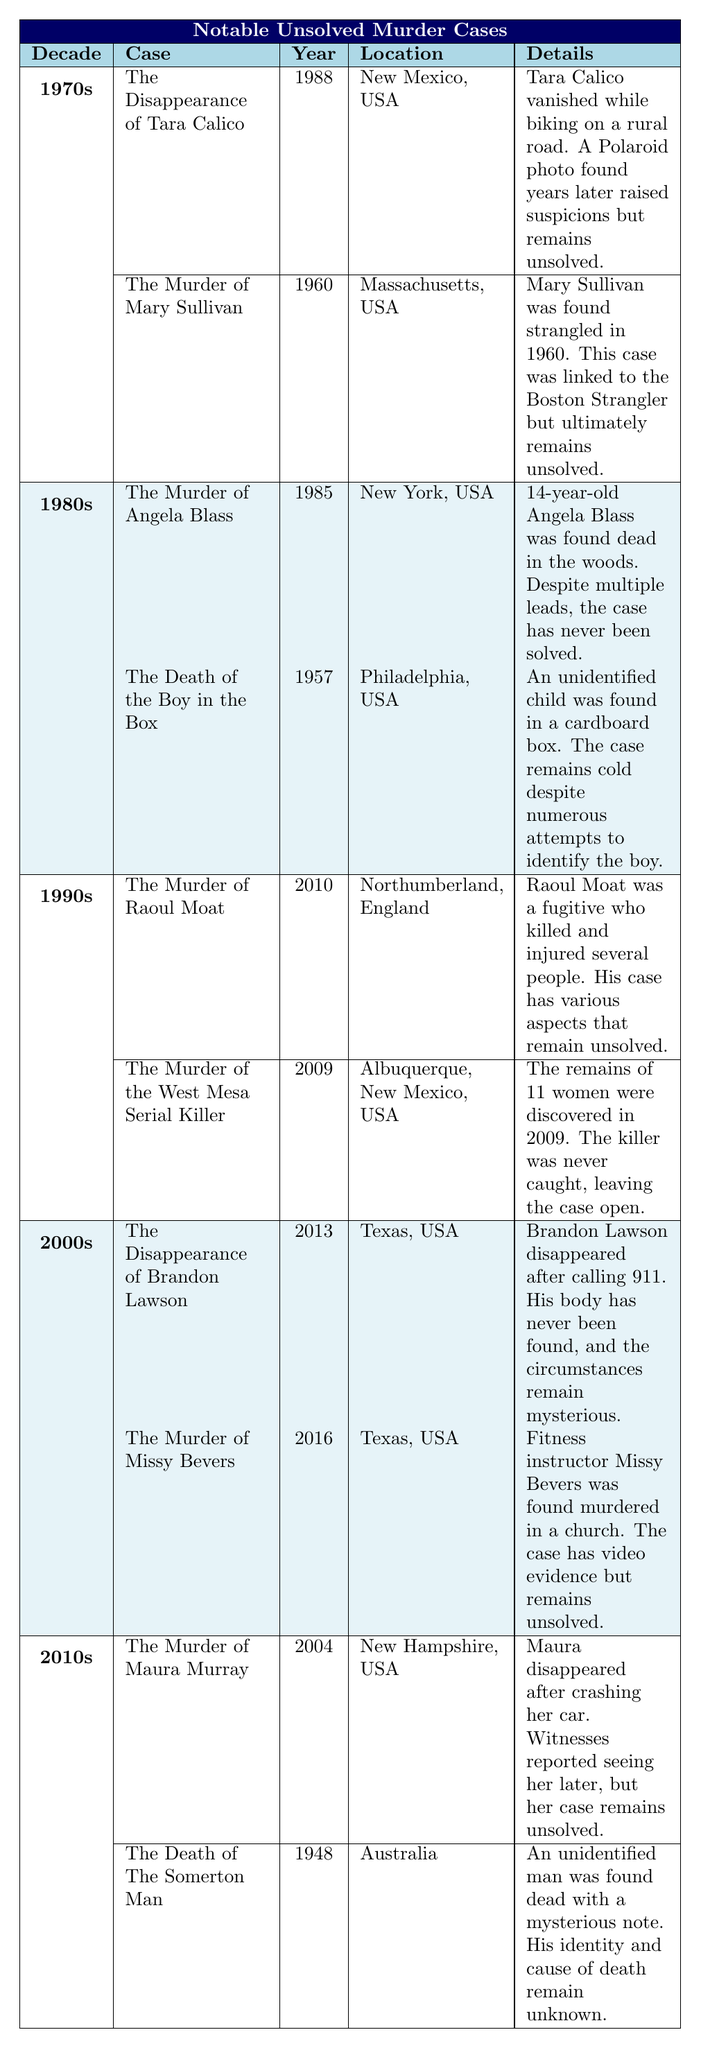What is the location of the murder case involving Maura Murray? According to the table, the location of the murder case involving Maura Murray is New Hampshire, USA.
Answer: New Hampshire, USA Which decade has the most unsolved murder cases listed in the table? By reviewing the table, there are two cases listed under the 1970s, two under the 1980s, two under the 1990s, two under the 2000s, and two under the 2010s. Therefore, all decades are equally represented with two cases each.
Answer: All decades are equally represented Is the murder of Angela Blass an unsolved case? The table explicitly states that the murder of Angela Blass remains unsolved despite multiple leads. Therefore, the answer is yes.
Answer: Yes What year did the Boy in the Box case occur? The table indicates that the Boy in the Box case occurred in 1957.
Answer: 1957 What is the total number of unsolved murder cases listed in the table? Counting the cases, there are 10 in total across the five decades: 2 (1970s) + 2 (1980s) + 2 (1990s) + 2 (2000s) + 2 (2010s) = 10.
Answer: 10 What details are provided about the murder of Missy Bevers? The table states that Missy Bevers, a fitness instructor, was found murdered in a church and that there is video evidence, but the case remains unsolved. This summarizes the key details regarding this case.
Answer: Found murdered in a church; has video evidence but unsolved In which year did the disappearance of Tara Calico occur? The table shows that the disappearance of Tara Calico occurred in 1988.
Answer: 1988 Are any of the cases linked to a known serial killer? Yes, the Murder of Mary Sullivan is linked to the Boston Strangler, which is mentioned in the details of that case in the table.
Answer: Yes What is the common characteristic of the cases listed from the 2000s? The common characteristic of the cases from the 2000s is that both involve individuals who disappeared or were found murdered under mysterious circumstances and remain unsolved.
Answer: They involve mysterious disappearances or murders and remain unsolved 